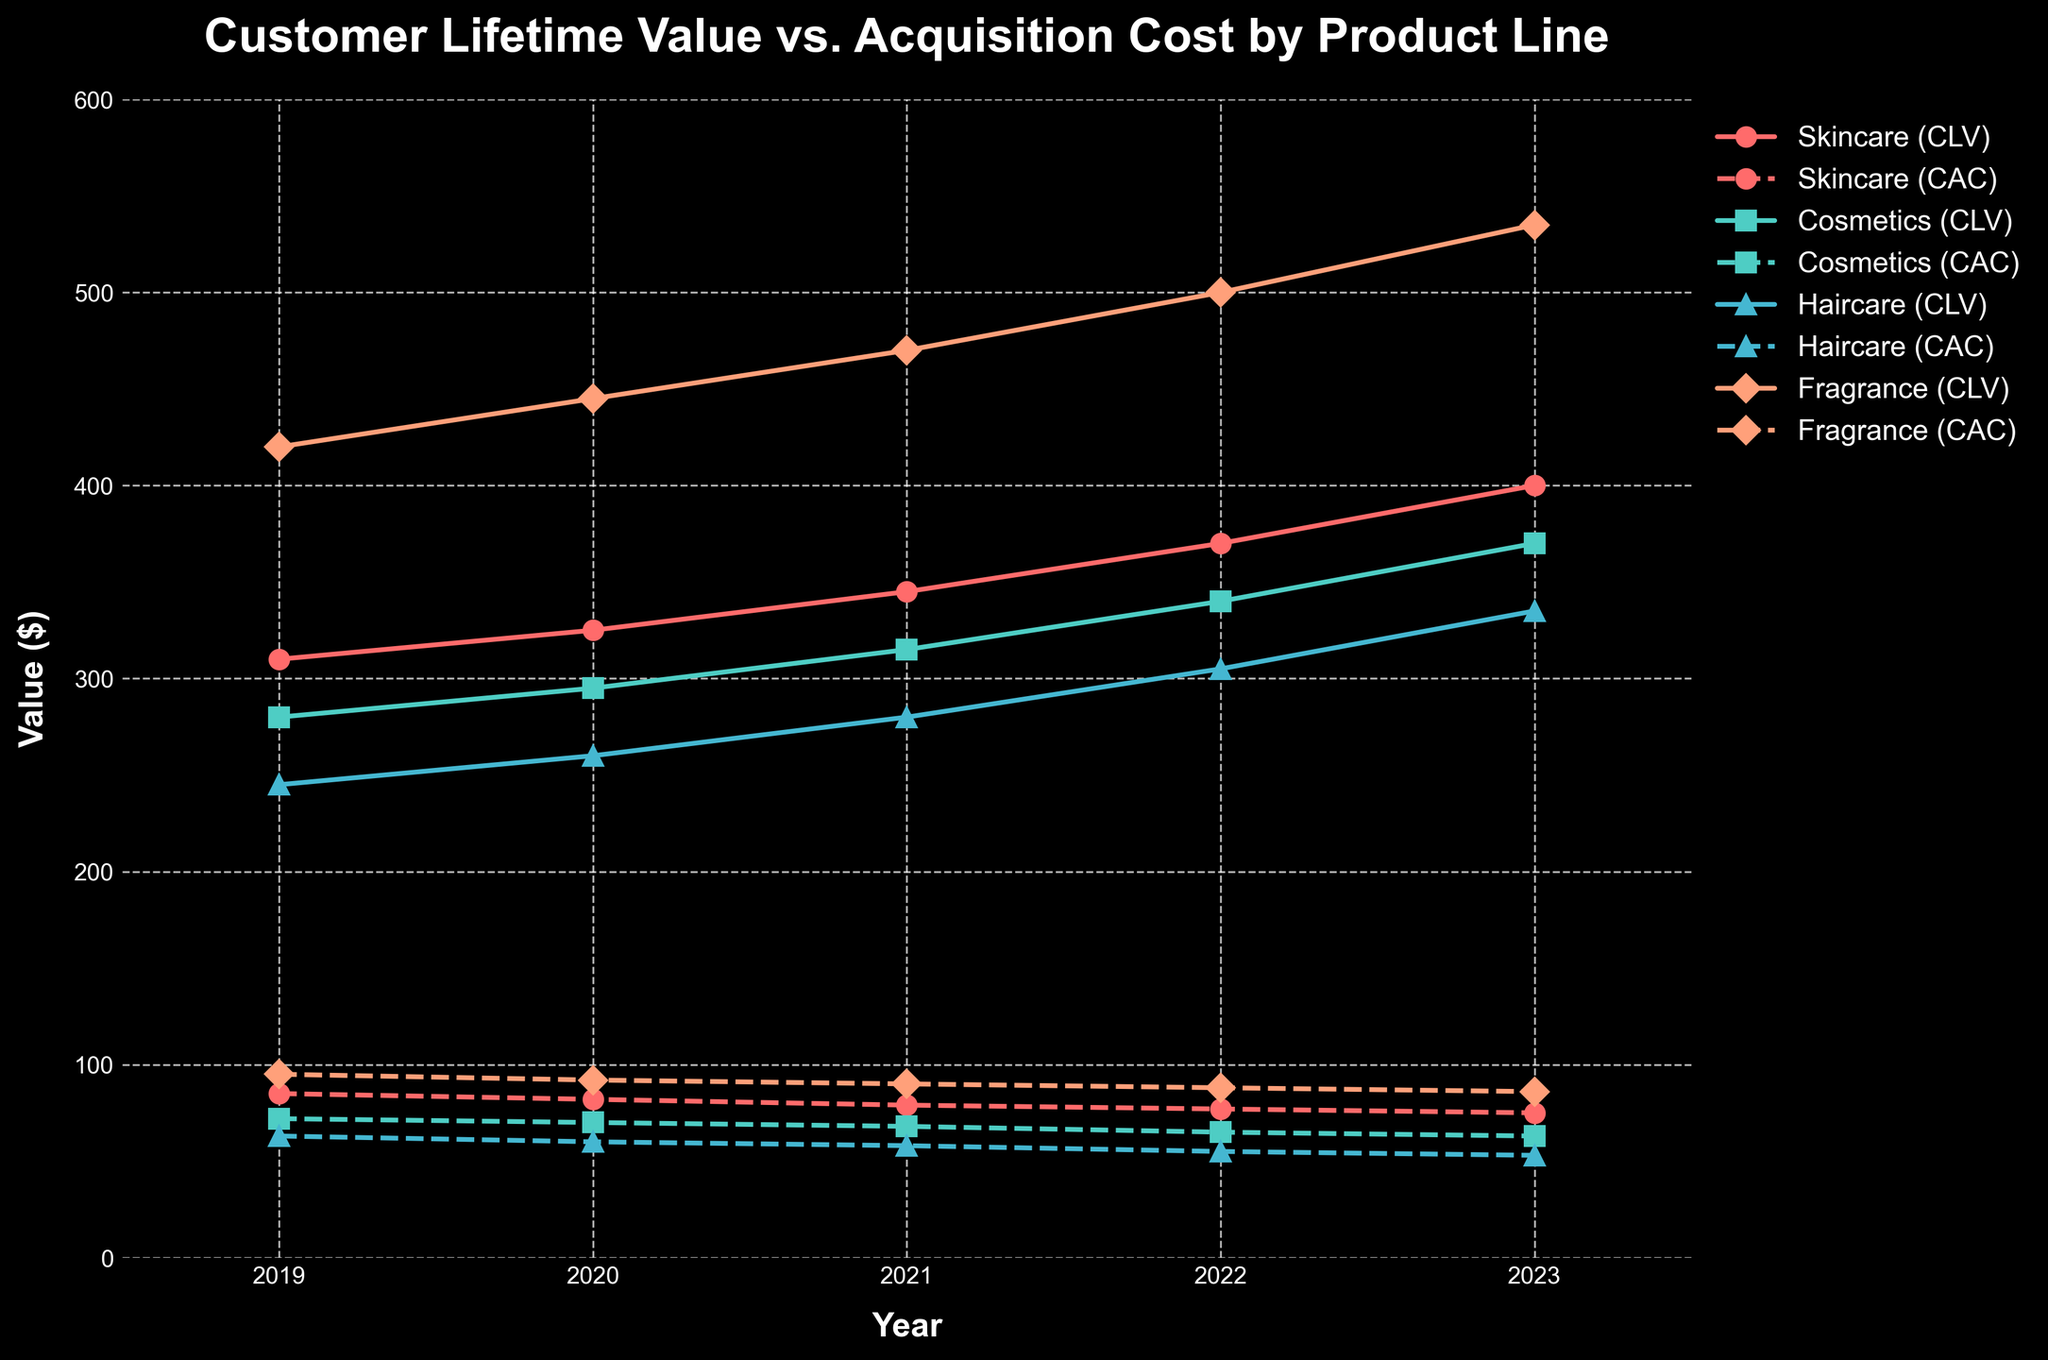What's the trend of Customer Lifetime Value (CLV) for the Skincare product line from 2019 to 2023? Observe the line labeled "Skincare (CLV)" from 2019 to 2023. It starts from 310 in 2019 and increases every year, reaching 400 in 2023.
Answer: Increasing Which product line had the highest Customer Acquisition Cost (CAC) in 2023? Look at the lines representing CAC values for 2023. The line labeled "Fragrance (CAC)" shows the highest CAC value in 2023 at 86.
Answer: Fragrance What is the difference between Customer Lifetime Value (CLV) and Customer Acquisition Cost (CAC) for Haircare in 2023? Check the 2023 values for Haircare. The CLV is 335 and the CAC is 53. The difference is 335 - 53.
Answer: 282 Compare the trends of Customer Acquisition Cost (CAC) for Cosmetics and Haircare from 2019 to 2023. Look at the lines labeled "Cosmetics (CAC)" and "Haircare (CAC)" from 2019 to 2023. Both lines show a decrease, with Cosmetics going from 72 to 63 and Haircare from 63 to 53.
Answer: Both decreasing What is the average Customer Lifetime Value (CLV) for Fragrance from 2019 to 2023? Sum the CLV values for Fragrance from 2019 to 2023 (420 + 445 + 470 + 500 + 535) and divide by 5. The sum is 2370.
Answer: 474 How does the Customer Acquisition Cost (CAC) for Skincare in 2023 compare to its CAC in 2019? The Skincare CAC was 85 in 2019 and 75 in 2023. The comparison shows a decrease of 10.
Answer: Decreased Which product line shows the most significant increase in Customer Lifetime Value (CLV) from 2019 to 2023? Compare the CLV lines for all product lines from 2019 to 2023. Fragrance increased from 420 to 535, which is the most significant change (115).
Answer: Fragrance What color represents the Cosmetics product line in the figure? Identify the line labeled "Cosmetics" in the graph and note its color, which is green.
Answer: Green What is the ratio of Customer Lifetime Value (CLV) to Customer Acquisition Cost (CAC) for the Skincare product line in 2022? For Skincare in 2022, the CLV is 370 and the CAC is 77. The ratio is 370/77.
Answer: 4.81 